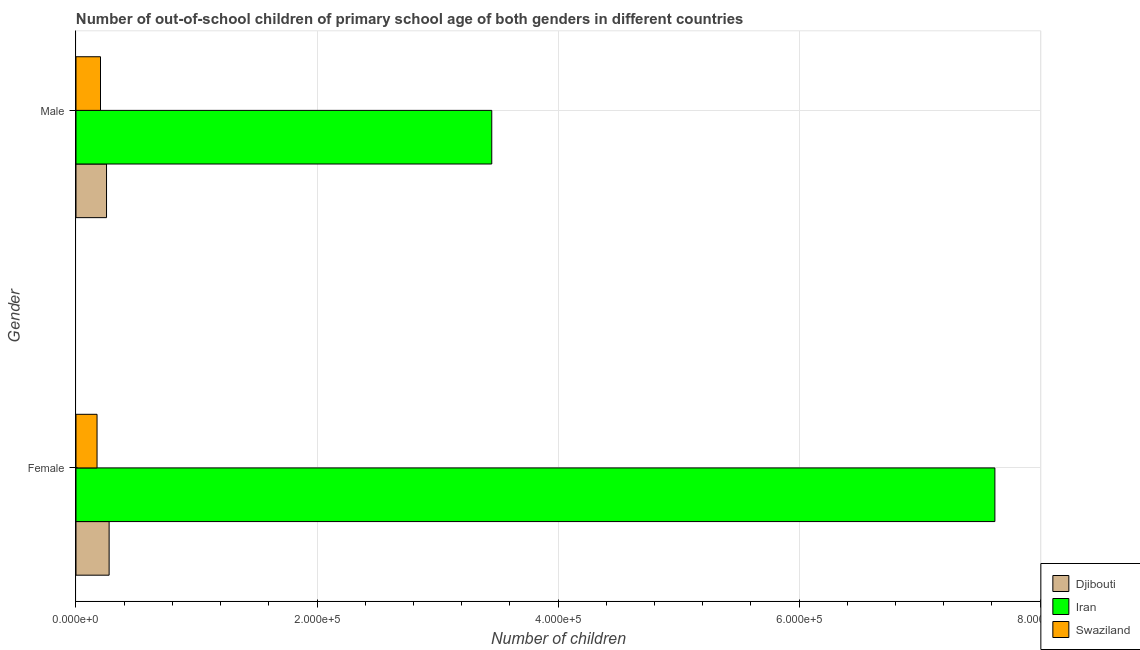How many different coloured bars are there?
Provide a short and direct response. 3. What is the number of female out-of-school students in Iran?
Give a very brief answer. 7.62e+05. Across all countries, what is the maximum number of female out-of-school students?
Your response must be concise. 7.62e+05. Across all countries, what is the minimum number of female out-of-school students?
Provide a short and direct response. 1.75e+04. In which country was the number of male out-of-school students maximum?
Your answer should be very brief. Iran. In which country was the number of male out-of-school students minimum?
Make the answer very short. Swaziland. What is the total number of female out-of-school students in the graph?
Keep it short and to the point. 8.07e+05. What is the difference between the number of female out-of-school students in Djibouti and that in Swaziland?
Keep it short and to the point. 1.00e+04. What is the difference between the number of female out-of-school students in Iran and the number of male out-of-school students in Swaziland?
Your response must be concise. 7.42e+05. What is the average number of female out-of-school students per country?
Give a very brief answer. 2.69e+05. What is the difference between the number of female out-of-school students and number of male out-of-school students in Swaziland?
Ensure brevity in your answer.  -2864. What is the ratio of the number of female out-of-school students in Iran to that in Djibouti?
Offer a terse response. 27.73. Is the number of male out-of-school students in Djibouti less than that in Iran?
Provide a succinct answer. Yes. In how many countries, is the number of female out-of-school students greater than the average number of female out-of-school students taken over all countries?
Your response must be concise. 1. What does the 1st bar from the top in Female represents?
Ensure brevity in your answer.  Swaziland. What does the 1st bar from the bottom in Male represents?
Your response must be concise. Djibouti. How many bars are there?
Ensure brevity in your answer.  6. Are all the bars in the graph horizontal?
Your answer should be compact. Yes. What is the difference between two consecutive major ticks on the X-axis?
Provide a succinct answer. 2.00e+05. Are the values on the major ticks of X-axis written in scientific E-notation?
Make the answer very short. Yes. Does the graph contain any zero values?
Give a very brief answer. No. Where does the legend appear in the graph?
Provide a short and direct response. Bottom right. How many legend labels are there?
Provide a short and direct response. 3. How are the legend labels stacked?
Provide a short and direct response. Vertical. What is the title of the graph?
Provide a short and direct response. Number of out-of-school children of primary school age of both genders in different countries. What is the label or title of the X-axis?
Provide a succinct answer. Number of children. What is the label or title of the Y-axis?
Give a very brief answer. Gender. What is the Number of children in Djibouti in Female?
Keep it short and to the point. 2.75e+04. What is the Number of children in Iran in Female?
Give a very brief answer. 7.62e+05. What is the Number of children in Swaziland in Female?
Your response must be concise. 1.75e+04. What is the Number of children in Djibouti in Male?
Give a very brief answer. 2.53e+04. What is the Number of children in Iran in Male?
Provide a short and direct response. 3.45e+05. What is the Number of children of Swaziland in Male?
Provide a succinct answer. 2.03e+04. Across all Gender, what is the maximum Number of children in Djibouti?
Your response must be concise. 2.75e+04. Across all Gender, what is the maximum Number of children of Iran?
Offer a very short reply. 7.62e+05. Across all Gender, what is the maximum Number of children in Swaziland?
Provide a succinct answer. 2.03e+04. Across all Gender, what is the minimum Number of children of Djibouti?
Keep it short and to the point. 2.53e+04. Across all Gender, what is the minimum Number of children of Iran?
Your response must be concise. 3.45e+05. Across all Gender, what is the minimum Number of children of Swaziland?
Offer a very short reply. 1.75e+04. What is the total Number of children of Djibouti in the graph?
Offer a very short reply. 5.28e+04. What is the total Number of children of Iran in the graph?
Your answer should be very brief. 1.11e+06. What is the total Number of children in Swaziland in the graph?
Offer a very short reply. 3.78e+04. What is the difference between the Number of children of Djibouti in Female and that in Male?
Provide a short and direct response. 2152. What is the difference between the Number of children of Iran in Female and that in Male?
Give a very brief answer. 4.17e+05. What is the difference between the Number of children of Swaziland in Female and that in Male?
Your answer should be very brief. -2864. What is the difference between the Number of children in Djibouti in Female and the Number of children in Iran in Male?
Give a very brief answer. -3.17e+05. What is the difference between the Number of children in Djibouti in Female and the Number of children in Swaziland in Male?
Your response must be concise. 7167. What is the difference between the Number of children of Iran in Female and the Number of children of Swaziland in Male?
Provide a succinct answer. 7.42e+05. What is the average Number of children of Djibouti per Gender?
Ensure brevity in your answer.  2.64e+04. What is the average Number of children of Iran per Gender?
Ensure brevity in your answer.  5.54e+05. What is the average Number of children in Swaziland per Gender?
Keep it short and to the point. 1.89e+04. What is the difference between the Number of children of Djibouti and Number of children of Iran in Female?
Offer a very short reply. -7.35e+05. What is the difference between the Number of children in Djibouti and Number of children in Swaziland in Female?
Your answer should be compact. 1.00e+04. What is the difference between the Number of children of Iran and Number of children of Swaziland in Female?
Provide a short and direct response. 7.45e+05. What is the difference between the Number of children of Djibouti and Number of children of Iran in Male?
Offer a very short reply. -3.20e+05. What is the difference between the Number of children of Djibouti and Number of children of Swaziland in Male?
Offer a terse response. 5015. What is the difference between the Number of children of Iran and Number of children of Swaziland in Male?
Keep it short and to the point. 3.25e+05. What is the ratio of the Number of children of Djibouti in Female to that in Male?
Make the answer very short. 1.08. What is the ratio of the Number of children of Iran in Female to that in Male?
Your answer should be compact. 2.21. What is the ratio of the Number of children of Swaziland in Female to that in Male?
Provide a succinct answer. 0.86. What is the difference between the highest and the second highest Number of children in Djibouti?
Make the answer very short. 2152. What is the difference between the highest and the second highest Number of children of Iran?
Offer a very short reply. 4.17e+05. What is the difference between the highest and the second highest Number of children in Swaziland?
Provide a succinct answer. 2864. What is the difference between the highest and the lowest Number of children in Djibouti?
Ensure brevity in your answer.  2152. What is the difference between the highest and the lowest Number of children in Iran?
Your answer should be compact. 4.17e+05. What is the difference between the highest and the lowest Number of children of Swaziland?
Ensure brevity in your answer.  2864. 